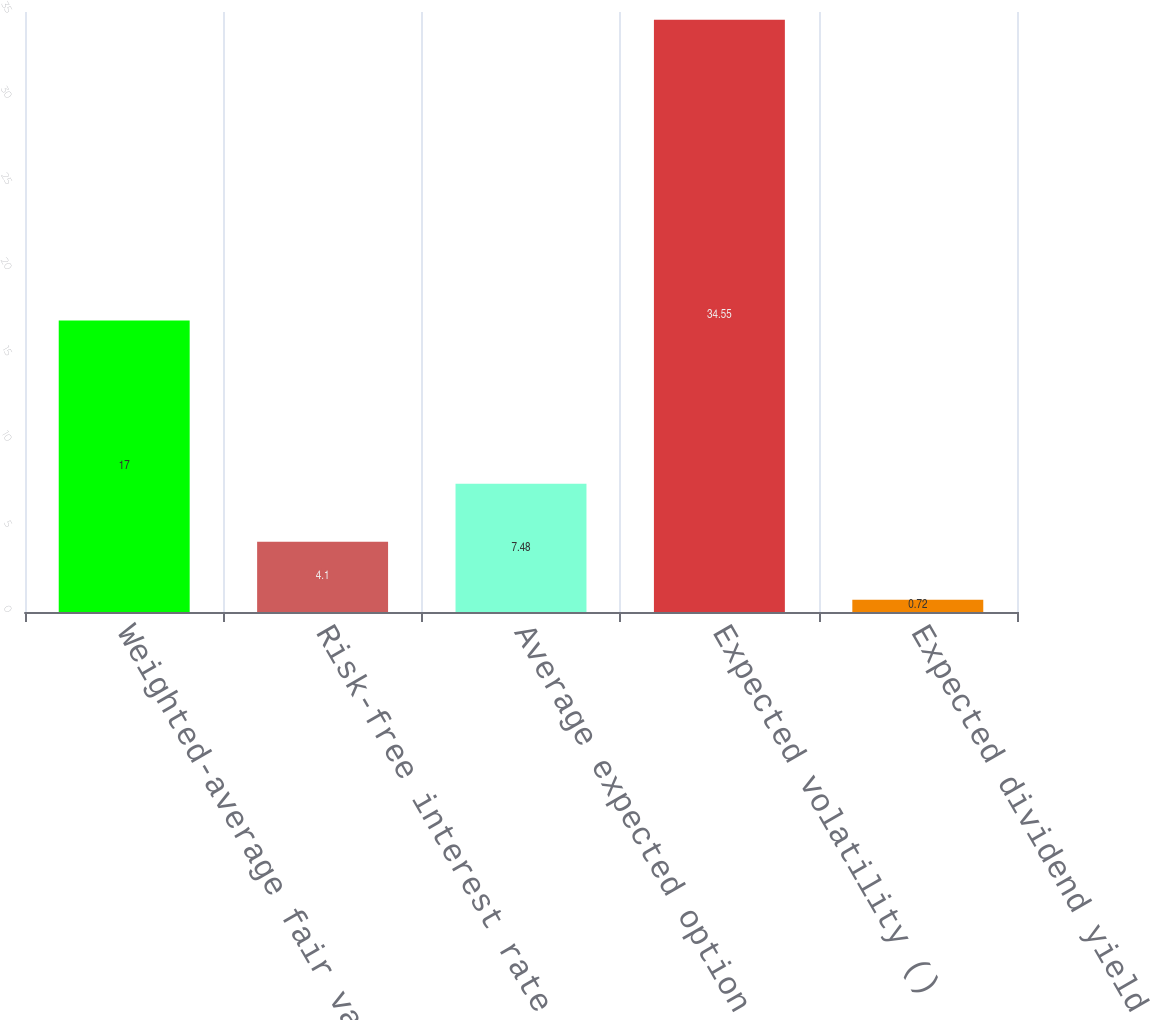<chart> <loc_0><loc_0><loc_500><loc_500><bar_chart><fcel>Weighted-average fair value ()<fcel>Risk-free interest rate ()<fcel>Average expected option life<fcel>Expected volatility ()<fcel>Expected dividend yield ()<nl><fcel>17<fcel>4.1<fcel>7.48<fcel>34.55<fcel>0.72<nl></chart> 